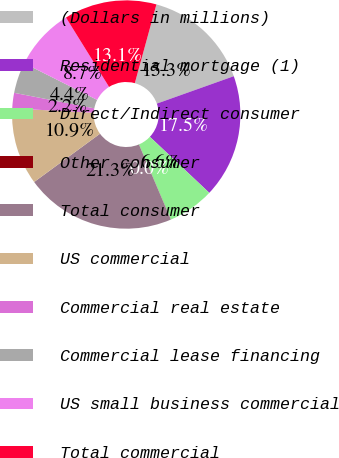Convert chart. <chart><loc_0><loc_0><loc_500><loc_500><pie_chart><fcel>(Dollars in millions)<fcel>Residential mortgage (1)<fcel>Direct/Indirect consumer<fcel>Other consumer<fcel>Total consumer<fcel>US commercial<fcel>Commercial real estate<fcel>Commercial lease financing<fcel>US small business commercial<fcel>Total commercial<nl><fcel>15.29%<fcel>17.48%<fcel>6.56%<fcel>0.01%<fcel>21.33%<fcel>10.92%<fcel>2.19%<fcel>4.37%<fcel>8.74%<fcel>13.11%<nl></chart> 